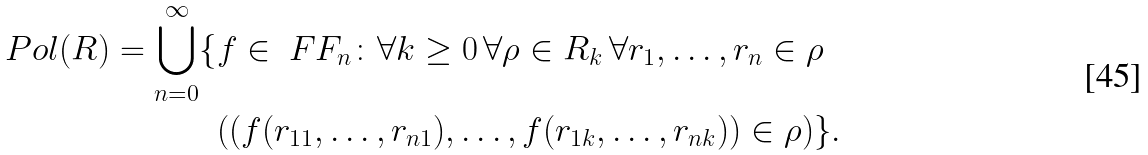Convert formula to latex. <formula><loc_0><loc_0><loc_500><loc_500>P o l ( R ) = \bigcup _ { n = 0 } ^ { \infty } \{ & f \in \ F F _ { n } \colon \forall k \geq 0 \, \forall \rho \in R _ { k } \, \forall r _ { 1 } , \dots , r _ { n } \in \rho \\ & ( ( f ( r _ { 1 1 } , \dots , r _ { n 1 } ) , \dots , f ( r _ { 1 k } , \dots , r _ { n k } ) ) \in \rho ) \} .</formula> 